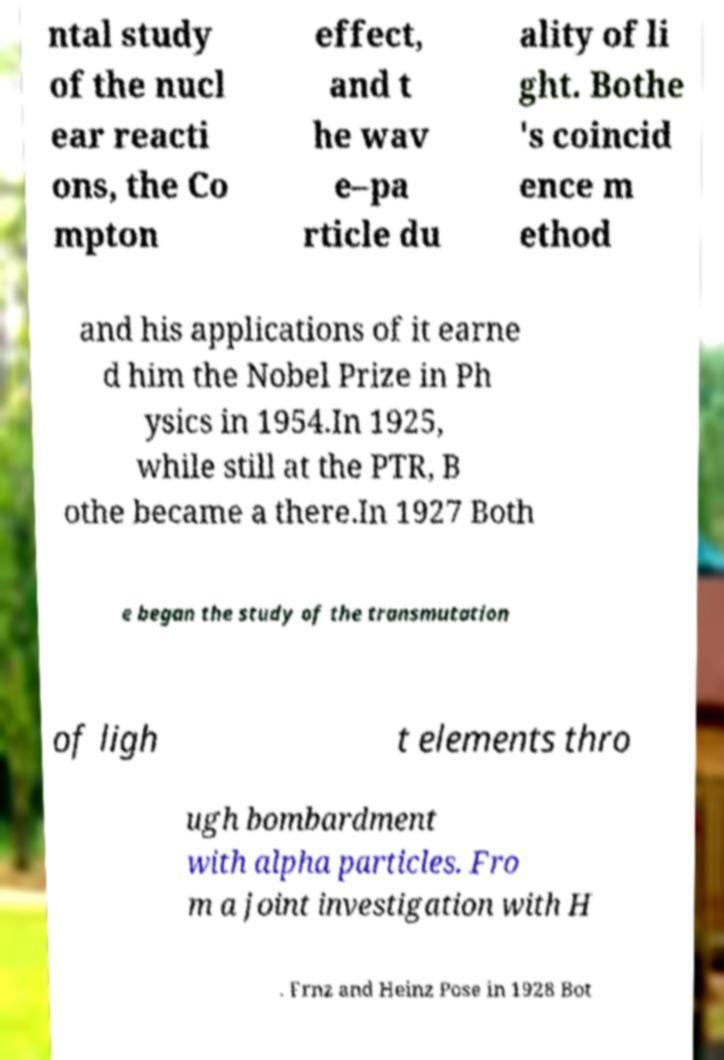Please identify and transcribe the text found in this image. ntal study of the nucl ear reacti ons, the Co mpton effect, and t he wav e–pa rticle du ality of li ght. Bothe 's coincid ence m ethod and his applications of it earne d him the Nobel Prize in Ph ysics in 1954.In 1925, while still at the PTR, B othe became a there.In 1927 Both e began the study of the transmutation of ligh t elements thro ugh bombardment with alpha particles. Fro m a joint investigation with H . Frnz and Heinz Pose in 1928 Bot 